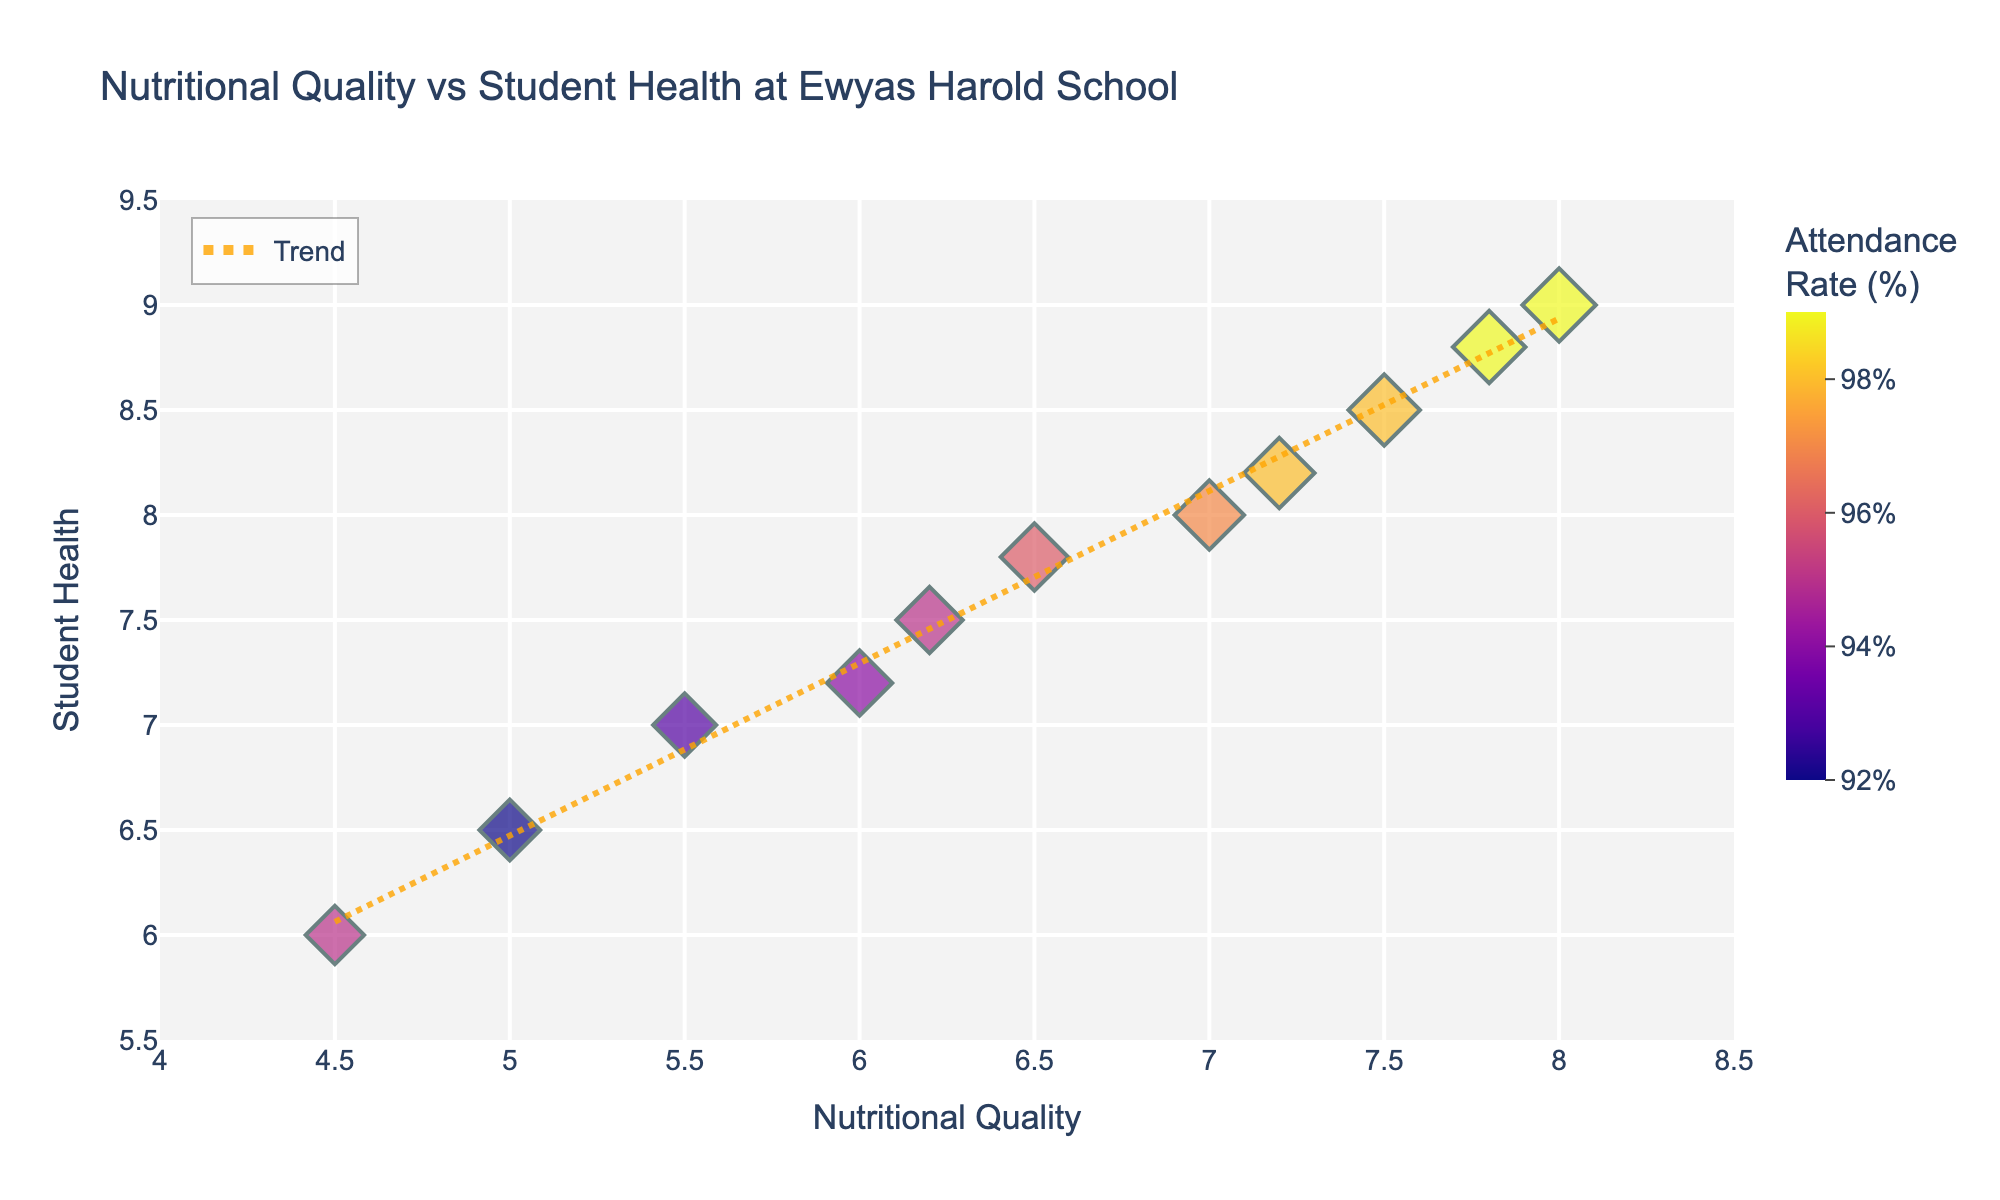What's the title of the figure? The title of the figure is usually displayed prominently at the top of the chart.
Answer: Nutritional Quality vs Student Health at Ewyas Harold School How many data points are displayed in the scatter plot? To determine the number of data points, you can count the individual markers on the scatter plot.
Answer: 11 Which date corresponds to the highest average student health score? By hovering over the scatter plot, you can find the date when the average student health score peaked. The highest score is 9.0 at the date of 2023-11-10.
Answer: 2023-11-10 What is the range of the Average Nutritional Quality Score? Looking at the x-axis range from the lowest to the highest point provides this information. This ranges from 4.5 to 8.0.
Answer: 4.5 to 8.0 What is the attendance rate when the nutritional quality score is 7.5? By finding the point with a nutritional quality score of 7.5, you can then check the associated attendance rate from the color or legend.
Answer: 98% How does the trend line slope indicate the relationship between nutritional quality and student health? The slope of the trend line shows whether there's a positive or negative correlation. A positive slope indicates an increase in nutritional quality is associated with an increase in student health.
Answer: Positive correlation Which data point has the highest attendance rate and what are its corresponding nutritional quality and health scores? By identifying the data point with the darkest color (highest attendance rate) and looking at the corresponding x and y coordinates, you find the answer.
Answer: Nutritional Quality: 8.0, Health Score: 9.0 Is there a significant increase in student health scores as the nutritional quality improves from 5.5 to 7.0? By comparing the y-values (student health scores) at nutritional quality scores of 5.5 and 7.0, you can observe the increase. The student health score rises from 7.0 to 8.0.
Answer: Yes Which nutritional quality score range shows the most improvement in student health scores? Observing the trend line and scatter plot helps identify where the steepest increase in student health scores occurs compared to the range of nutritional quality scores. There’s noticeable improvement between scores of 5.0 to 7.0.
Answer: 5.0 to 7.0 